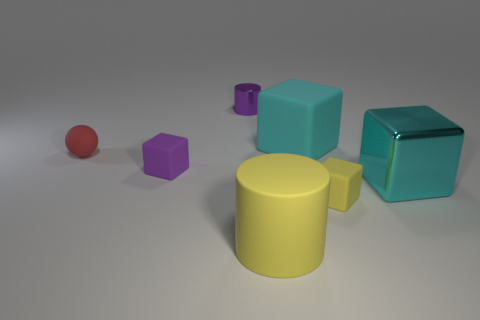There is a big thing to the right of the small yellow thing; is it the same color as the large matte thing that is on the right side of the large yellow rubber cylinder?
Offer a very short reply. Yes. How big is the shiny object behind the red thing left of the cyan cube behind the tiny purple block?
Offer a very short reply. Small. There is another large thing that is the same shape as the large metal thing; what is its color?
Offer a very short reply. Cyan. Is the number of tiny things on the left side of the yellow cylinder greater than the number of big yellow matte cylinders?
Your answer should be compact. Yes. Does the small yellow thing have the same shape as the purple object behind the purple matte block?
Your response must be concise. No. Is there any other thing that is the same size as the shiny cylinder?
Keep it short and to the point. Yes. There is a cyan metal thing that is the same shape as the cyan matte object; what is its size?
Provide a short and direct response. Large. Are there more tiny green matte things than big yellow rubber things?
Ensure brevity in your answer.  No. Is the red rubber object the same shape as the small yellow object?
Ensure brevity in your answer.  No. The red thing that is in front of the cyan thing to the left of the cyan metallic thing is made of what material?
Ensure brevity in your answer.  Rubber. 